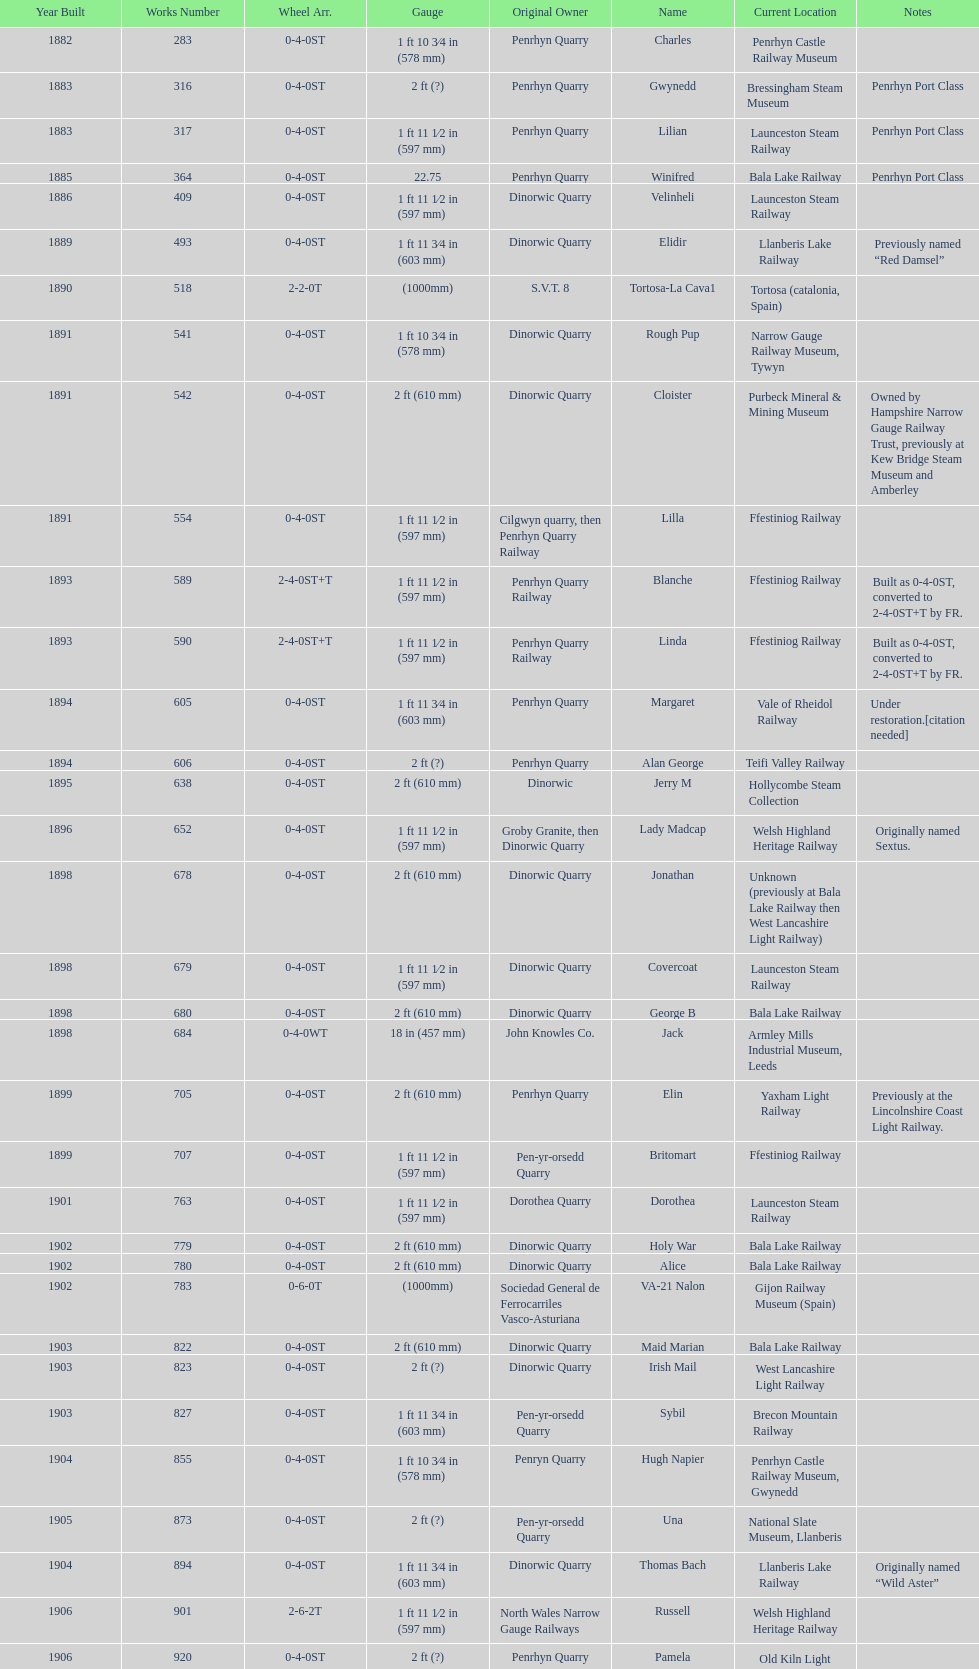What is the working number of the unique piece created in 1882? 283. 